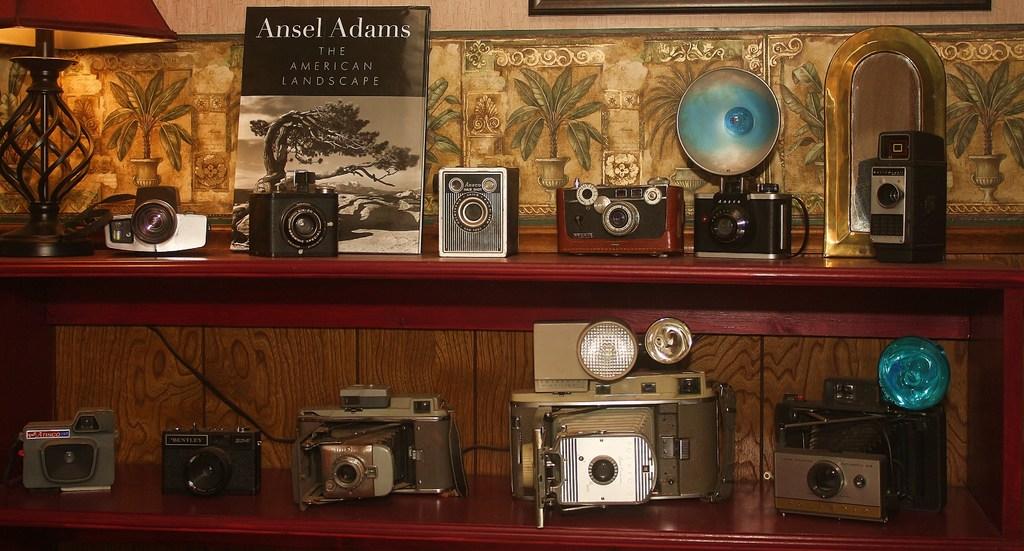What text is written in white in the background book?
Offer a very short reply. Ansel adams. 